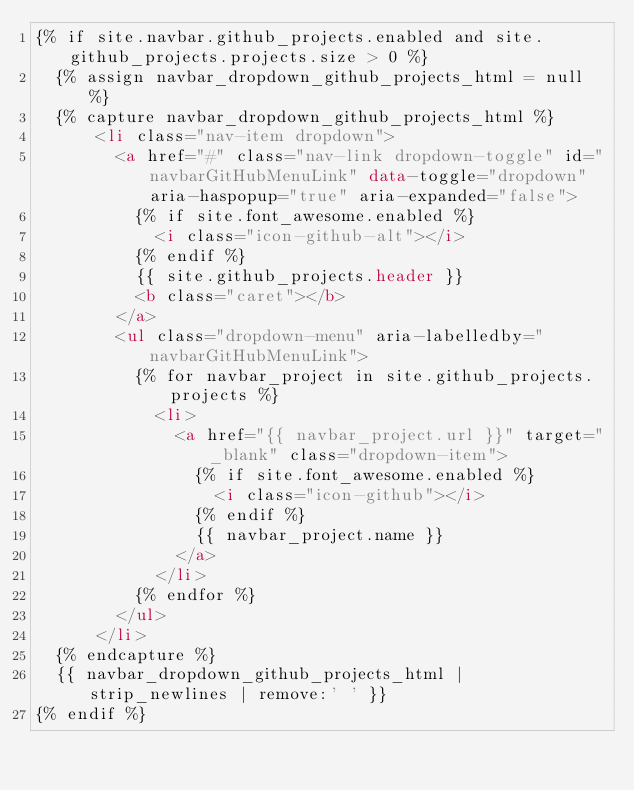<code> <loc_0><loc_0><loc_500><loc_500><_HTML_>{% if site.navbar.github_projects.enabled and site.github_projects.projects.size > 0 %}
	{% assign navbar_dropdown_github_projects_html = null %}
	{% capture navbar_dropdown_github_projects_html %}
			<li class="nav-item dropdown">
				<a href="#" class="nav-link dropdown-toggle" id="navbarGitHubMenuLink" data-toggle="dropdown" aria-haspopup="true" aria-expanded="false">
					{% if site.font_awesome.enabled %}
						<i class="icon-github-alt"></i> 
					{% endif %}
					{{ site.github_projects.header }} 
					<b class="caret"></b>
				</a>
				<ul class="dropdown-menu" aria-labelledby="navbarGitHubMenuLink">
					{% for navbar_project in site.github_projects.projects %}
						<li>
							<a href="{{ navbar_project.url }}" target="_blank" class="dropdown-item">
								{% if site.font_awesome.enabled %}
									<i class="icon-github"></i> 
								{% endif %}
								{{ navbar_project.name }}
							</a>
						</li>
					{% endfor %}
				</ul>
			</li>
	{% endcapture %}
	{{ navbar_dropdown_github_projects_html | strip_newlines | remove:'	' }}
{% endif %}</code> 